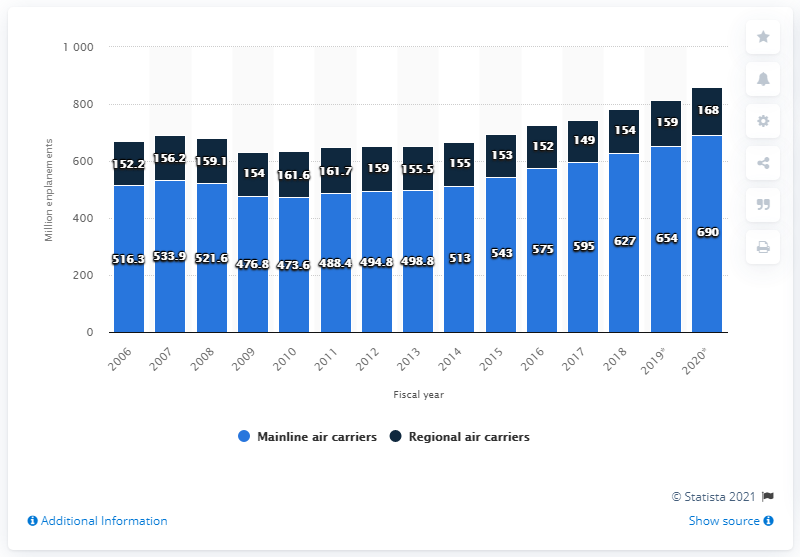Draw attention to some important aspects in this diagram. There were 654,000 U.S. domestic mainline air carrier enplanements in 2019. There were 159,000 regional air carrier enplanements in 2019. 